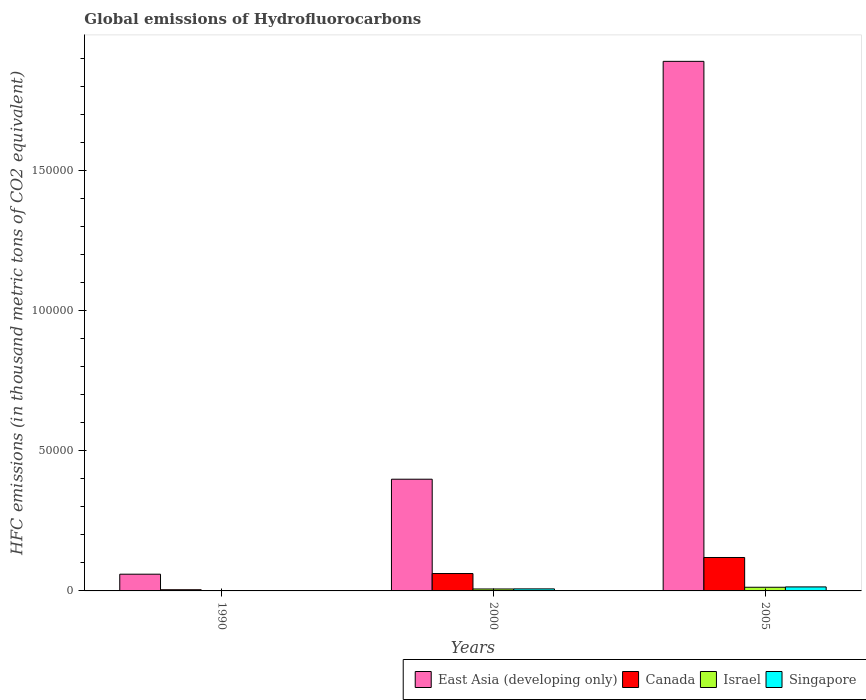How many different coloured bars are there?
Keep it short and to the point. 4. How many groups of bars are there?
Provide a succinct answer. 3. Are the number of bars per tick equal to the number of legend labels?
Make the answer very short. Yes. Are the number of bars on each tick of the X-axis equal?
Keep it short and to the point. Yes. How many bars are there on the 1st tick from the left?
Give a very brief answer. 4. How many bars are there on the 3rd tick from the right?
Your answer should be very brief. 4. What is the label of the 2nd group of bars from the left?
Your answer should be compact. 2000. In how many cases, is the number of bars for a given year not equal to the number of legend labels?
Ensure brevity in your answer.  0. What is the global emissions of Hydrofluorocarbons in Canada in 2000?
Make the answer very short. 6202.8. Across all years, what is the maximum global emissions of Hydrofluorocarbons in East Asia (developing only)?
Offer a terse response. 1.89e+05. In which year was the global emissions of Hydrofluorocarbons in Canada minimum?
Your answer should be compact. 1990. What is the total global emissions of Hydrofluorocarbons in Israel in the graph?
Make the answer very short. 2001.5. What is the difference between the global emissions of Hydrofluorocarbons in Canada in 1990 and that in 2005?
Keep it short and to the point. -1.15e+04. What is the difference between the global emissions of Hydrofluorocarbons in East Asia (developing only) in 2005 and the global emissions of Hydrofluorocarbons in Israel in 1990?
Offer a very short reply. 1.89e+05. What is the average global emissions of Hydrofluorocarbons in Israel per year?
Your response must be concise. 667.17. In the year 2005, what is the difference between the global emissions of Hydrofluorocarbons in Singapore and global emissions of Hydrofluorocarbons in East Asia (developing only)?
Your response must be concise. -1.88e+05. In how many years, is the global emissions of Hydrofluorocarbons in Canada greater than 180000 thousand metric tons?
Your answer should be compact. 0. What is the ratio of the global emissions of Hydrofluorocarbons in Canada in 2000 to that in 2005?
Provide a short and direct response. 0.52. Is the difference between the global emissions of Hydrofluorocarbons in Singapore in 1990 and 2005 greater than the difference between the global emissions of Hydrofluorocarbons in East Asia (developing only) in 1990 and 2005?
Give a very brief answer. Yes. What is the difference between the highest and the second highest global emissions of Hydrofluorocarbons in East Asia (developing only)?
Give a very brief answer. 1.49e+05. What is the difference between the highest and the lowest global emissions of Hydrofluorocarbons in Singapore?
Offer a very short reply. 1417.1. In how many years, is the global emissions of Hydrofluorocarbons in Singapore greater than the average global emissions of Hydrofluorocarbons in Singapore taken over all years?
Provide a short and direct response. 2. What does the 2nd bar from the right in 1990 represents?
Provide a succinct answer. Israel. How many years are there in the graph?
Ensure brevity in your answer.  3. Are the values on the major ticks of Y-axis written in scientific E-notation?
Your answer should be very brief. No. Does the graph contain any zero values?
Your answer should be compact. No. Where does the legend appear in the graph?
Your response must be concise. Bottom right. How are the legend labels stacked?
Your answer should be very brief. Horizontal. What is the title of the graph?
Keep it short and to the point. Global emissions of Hydrofluorocarbons. Does "Singapore" appear as one of the legend labels in the graph?
Provide a succinct answer. Yes. What is the label or title of the Y-axis?
Offer a terse response. HFC emissions (in thousand metric tons of CO2 equivalent). What is the HFC emissions (in thousand metric tons of CO2 equivalent) in East Asia (developing only) in 1990?
Ensure brevity in your answer.  5970.4. What is the HFC emissions (in thousand metric tons of CO2 equivalent) in Canada in 1990?
Offer a very short reply. 418.5. What is the HFC emissions (in thousand metric tons of CO2 equivalent) of Israel in 1990?
Your response must be concise. 4.6. What is the HFC emissions (in thousand metric tons of CO2 equivalent) in East Asia (developing only) in 2000?
Provide a succinct answer. 3.99e+04. What is the HFC emissions (in thousand metric tons of CO2 equivalent) in Canada in 2000?
Give a very brief answer. 6202.8. What is the HFC emissions (in thousand metric tons of CO2 equivalent) in Israel in 2000?
Your answer should be very brief. 691.9. What is the HFC emissions (in thousand metric tons of CO2 equivalent) of Singapore in 2000?
Offer a terse response. 728.9. What is the HFC emissions (in thousand metric tons of CO2 equivalent) in East Asia (developing only) in 2005?
Your answer should be compact. 1.89e+05. What is the HFC emissions (in thousand metric tons of CO2 equivalent) of Canada in 2005?
Ensure brevity in your answer.  1.19e+04. What is the HFC emissions (in thousand metric tons of CO2 equivalent) of Israel in 2005?
Provide a short and direct response. 1305. What is the HFC emissions (in thousand metric tons of CO2 equivalent) in Singapore in 2005?
Your response must be concise. 1429.7. Across all years, what is the maximum HFC emissions (in thousand metric tons of CO2 equivalent) in East Asia (developing only)?
Your response must be concise. 1.89e+05. Across all years, what is the maximum HFC emissions (in thousand metric tons of CO2 equivalent) in Canada?
Offer a terse response. 1.19e+04. Across all years, what is the maximum HFC emissions (in thousand metric tons of CO2 equivalent) in Israel?
Keep it short and to the point. 1305. Across all years, what is the maximum HFC emissions (in thousand metric tons of CO2 equivalent) of Singapore?
Offer a very short reply. 1429.7. Across all years, what is the minimum HFC emissions (in thousand metric tons of CO2 equivalent) in East Asia (developing only)?
Ensure brevity in your answer.  5970.4. Across all years, what is the minimum HFC emissions (in thousand metric tons of CO2 equivalent) in Canada?
Provide a succinct answer. 418.5. What is the total HFC emissions (in thousand metric tons of CO2 equivalent) in East Asia (developing only) in the graph?
Your answer should be very brief. 2.35e+05. What is the total HFC emissions (in thousand metric tons of CO2 equivalent) of Canada in the graph?
Make the answer very short. 1.85e+04. What is the total HFC emissions (in thousand metric tons of CO2 equivalent) in Israel in the graph?
Make the answer very short. 2001.5. What is the total HFC emissions (in thousand metric tons of CO2 equivalent) in Singapore in the graph?
Your response must be concise. 2171.2. What is the difference between the HFC emissions (in thousand metric tons of CO2 equivalent) of East Asia (developing only) in 1990 and that in 2000?
Offer a terse response. -3.39e+04. What is the difference between the HFC emissions (in thousand metric tons of CO2 equivalent) in Canada in 1990 and that in 2000?
Provide a short and direct response. -5784.3. What is the difference between the HFC emissions (in thousand metric tons of CO2 equivalent) of Israel in 1990 and that in 2000?
Give a very brief answer. -687.3. What is the difference between the HFC emissions (in thousand metric tons of CO2 equivalent) of Singapore in 1990 and that in 2000?
Keep it short and to the point. -716.3. What is the difference between the HFC emissions (in thousand metric tons of CO2 equivalent) of East Asia (developing only) in 1990 and that in 2005?
Your response must be concise. -1.83e+05. What is the difference between the HFC emissions (in thousand metric tons of CO2 equivalent) in Canada in 1990 and that in 2005?
Ensure brevity in your answer.  -1.15e+04. What is the difference between the HFC emissions (in thousand metric tons of CO2 equivalent) in Israel in 1990 and that in 2005?
Offer a terse response. -1300.4. What is the difference between the HFC emissions (in thousand metric tons of CO2 equivalent) of Singapore in 1990 and that in 2005?
Provide a short and direct response. -1417.1. What is the difference between the HFC emissions (in thousand metric tons of CO2 equivalent) in East Asia (developing only) in 2000 and that in 2005?
Make the answer very short. -1.49e+05. What is the difference between the HFC emissions (in thousand metric tons of CO2 equivalent) of Canada in 2000 and that in 2005?
Offer a terse response. -5725.6. What is the difference between the HFC emissions (in thousand metric tons of CO2 equivalent) of Israel in 2000 and that in 2005?
Offer a very short reply. -613.1. What is the difference between the HFC emissions (in thousand metric tons of CO2 equivalent) in Singapore in 2000 and that in 2005?
Your answer should be very brief. -700.8. What is the difference between the HFC emissions (in thousand metric tons of CO2 equivalent) of East Asia (developing only) in 1990 and the HFC emissions (in thousand metric tons of CO2 equivalent) of Canada in 2000?
Your answer should be very brief. -232.4. What is the difference between the HFC emissions (in thousand metric tons of CO2 equivalent) of East Asia (developing only) in 1990 and the HFC emissions (in thousand metric tons of CO2 equivalent) of Israel in 2000?
Give a very brief answer. 5278.5. What is the difference between the HFC emissions (in thousand metric tons of CO2 equivalent) in East Asia (developing only) in 1990 and the HFC emissions (in thousand metric tons of CO2 equivalent) in Singapore in 2000?
Your answer should be compact. 5241.5. What is the difference between the HFC emissions (in thousand metric tons of CO2 equivalent) of Canada in 1990 and the HFC emissions (in thousand metric tons of CO2 equivalent) of Israel in 2000?
Ensure brevity in your answer.  -273.4. What is the difference between the HFC emissions (in thousand metric tons of CO2 equivalent) in Canada in 1990 and the HFC emissions (in thousand metric tons of CO2 equivalent) in Singapore in 2000?
Make the answer very short. -310.4. What is the difference between the HFC emissions (in thousand metric tons of CO2 equivalent) in Israel in 1990 and the HFC emissions (in thousand metric tons of CO2 equivalent) in Singapore in 2000?
Provide a short and direct response. -724.3. What is the difference between the HFC emissions (in thousand metric tons of CO2 equivalent) in East Asia (developing only) in 1990 and the HFC emissions (in thousand metric tons of CO2 equivalent) in Canada in 2005?
Give a very brief answer. -5958. What is the difference between the HFC emissions (in thousand metric tons of CO2 equivalent) in East Asia (developing only) in 1990 and the HFC emissions (in thousand metric tons of CO2 equivalent) in Israel in 2005?
Your answer should be compact. 4665.4. What is the difference between the HFC emissions (in thousand metric tons of CO2 equivalent) of East Asia (developing only) in 1990 and the HFC emissions (in thousand metric tons of CO2 equivalent) of Singapore in 2005?
Provide a short and direct response. 4540.7. What is the difference between the HFC emissions (in thousand metric tons of CO2 equivalent) in Canada in 1990 and the HFC emissions (in thousand metric tons of CO2 equivalent) in Israel in 2005?
Your answer should be very brief. -886.5. What is the difference between the HFC emissions (in thousand metric tons of CO2 equivalent) in Canada in 1990 and the HFC emissions (in thousand metric tons of CO2 equivalent) in Singapore in 2005?
Provide a short and direct response. -1011.2. What is the difference between the HFC emissions (in thousand metric tons of CO2 equivalent) of Israel in 1990 and the HFC emissions (in thousand metric tons of CO2 equivalent) of Singapore in 2005?
Provide a succinct answer. -1425.1. What is the difference between the HFC emissions (in thousand metric tons of CO2 equivalent) in East Asia (developing only) in 2000 and the HFC emissions (in thousand metric tons of CO2 equivalent) in Canada in 2005?
Give a very brief answer. 2.79e+04. What is the difference between the HFC emissions (in thousand metric tons of CO2 equivalent) in East Asia (developing only) in 2000 and the HFC emissions (in thousand metric tons of CO2 equivalent) in Israel in 2005?
Your response must be concise. 3.86e+04. What is the difference between the HFC emissions (in thousand metric tons of CO2 equivalent) of East Asia (developing only) in 2000 and the HFC emissions (in thousand metric tons of CO2 equivalent) of Singapore in 2005?
Your answer should be compact. 3.84e+04. What is the difference between the HFC emissions (in thousand metric tons of CO2 equivalent) of Canada in 2000 and the HFC emissions (in thousand metric tons of CO2 equivalent) of Israel in 2005?
Provide a short and direct response. 4897.8. What is the difference between the HFC emissions (in thousand metric tons of CO2 equivalent) in Canada in 2000 and the HFC emissions (in thousand metric tons of CO2 equivalent) in Singapore in 2005?
Offer a very short reply. 4773.1. What is the difference between the HFC emissions (in thousand metric tons of CO2 equivalent) of Israel in 2000 and the HFC emissions (in thousand metric tons of CO2 equivalent) of Singapore in 2005?
Offer a terse response. -737.8. What is the average HFC emissions (in thousand metric tons of CO2 equivalent) in East Asia (developing only) per year?
Give a very brief answer. 7.83e+04. What is the average HFC emissions (in thousand metric tons of CO2 equivalent) of Canada per year?
Your answer should be very brief. 6183.23. What is the average HFC emissions (in thousand metric tons of CO2 equivalent) in Israel per year?
Offer a terse response. 667.17. What is the average HFC emissions (in thousand metric tons of CO2 equivalent) in Singapore per year?
Offer a very short reply. 723.73. In the year 1990, what is the difference between the HFC emissions (in thousand metric tons of CO2 equivalent) of East Asia (developing only) and HFC emissions (in thousand metric tons of CO2 equivalent) of Canada?
Provide a succinct answer. 5551.9. In the year 1990, what is the difference between the HFC emissions (in thousand metric tons of CO2 equivalent) of East Asia (developing only) and HFC emissions (in thousand metric tons of CO2 equivalent) of Israel?
Provide a succinct answer. 5965.8. In the year 1990, what is the difference between the HFC emissions (in thousand metric tons of CO2 equivalent) of East Asia (developing only) and HFC emissions (in thousand metric tons of CO2 equivalent) of Singapore?
Your answer should be compact. 5957.8. In the year 1990, what is the difference between the HFC emissions (in thousand metric tons of CO2 equivalent) in Canada and HFC emissions (in thousand metric tons of CO2 equivalent) in Israel?
Give a very brief answer. 413.9. In the year 1990, what is the difference between the HFC emissions (in thousand metric tons of CO2 equivalent) in Canada and HFC emissions (in thousand metric tons of CO2 equivalent) in Singapore?
Keep it short and to the point. 405.9. In the year 1990, what is the difference between the HFC emissions (in thousand metric tons of CO2 equivalent) in Israel and HFC emissions (in thousand metric tons of CO2 equivalent) in Singapore?
Your answer should be compact. -8. In the year 2000, what is the difference between the HFC emissions (in thousand metric tons of CO2 equivalent) in East Asia (developing only) and HFC emissions (in thousand metric tons of CO2 equivalent) in Canada?
Your answer should be very brief. 3.37e+04. In the year 2000, what is the difference between the HFC emissions (in thousand metric tons of CO2 equivalent) in East Asia (developing only) and HFC emissions (in thousand metric tons of CO2 equivalent) in Israel?
Provide a short and direct response. 3.92e+04. In the year 2000, what is the difference between the HFC emissions (in thousand metric tons of CO2 equivalent) of East Asia (developing only) and HFC emissions (in thousand metric tons of CO2 equivalent) of Singapore?
Your response must be concise. 3.91e+04. In the year 2000, what is the difference between the HFC emissions (in thousand metric tons of CO2 equivalent) in Canada and HFC emissions (in thousand metric tons of CO2 equivalent) in Israel?
Your answer should be very brief. 5510.9. In the year 2000, what is the difference between the HFC emissions (in thousand metric tons of CO2 equivalent) in Canada and HFC emissions (in thousand metric tons of CO2 equivalent) in Singapore?
Your response must be concise. 5473.9. In the year 2000, what is the difference between the HFC emissions (in thousand metric tons of CO2 equivalent) in Israel and HFC emissions (in thousand metric tons of CO2 equivalent) in Singapore?
Offer a terse response. -37. In the year 2005, what is the difference between the HFC emissions (in thousand metric tons of CO2 equivalent) of East Asia (developing only) and HFC emissions (in thousand metric tons of CO2 equivalent) of Canada?
Ensure brevity in your answer.  1.77e+05. In the year 2005, what is the difference between the HFC emissions (in thousand metric tons of CO2 equivalent) of East Asia (developing only) and HFC emissions (in thousand metric tons of CO2 equivalent) of Israel?
Your answer should be very brief. 1.88e+05. In the year 2005, what is the difference between the HFC emissions (in thousand metric tons of CO2 equivalent) of East Asia (developing only) and HFC emissions (in thousand metric tons of CO2 equivalent) of Singapore?
Give a very brief answer. 1.88e+05. In the year 2005, what is the difference between the HFC emissions (in thousand metric tons of CO2 equivalent) of Canada and HFC emissions (in thousand metric tons of CO2 equivalent) of Israel?
Give a very brief answer. 1.06e+04. In the year 2005, what is the difference between the HFC emissions (in thousand metric tons of CO2 equivalent) of Canada and HFC emissions (in thousand metric tons of CO2 equivalent) of Singapore?
Offer a terse response. 1.05e+04. In the year 2005, what is the difference between the HFC emissions (in thousand metric tons of CO2 equivalent) of Israel and HFC emissions (in thousand metric tons of CO2 equivalent) of Singapore?
Ensure brevity in your answer.  -124.7. What is the ratio of the HFC emissions (in thousand metric tons of CO2 equivalent) in East Asia (developing only) in 1990 to that in 2000?
Offer a terse response. 0.15. What is the ratio of the HFC emissions (in thousand metric tons of CO2 equivalent) in Canada in 1990 to that in 2000?
Offer a terse response. 0.07. What is the ratio of the HFC emissions (in thousand metric tons of CO2 equivalent) of Israel in 1990 to that in 2000?
Make the answer very short. 0.01. What is the ratio of the HFC emissions (in thousand metric tons of CO2 equivalent) in Singapore in 1990 to that in 2000?
Provide a short and direct response. 0.02. What is the ratio of the HFC emissions (in thousand metric tons of CO2 equivalent) in East Asia (developing only) in 1990 to that in 2005?
Make the answer very short. 0.03. What is the ratio of the HFC emissions (in thousand metric tons of CO2 equivalent) of Canada in 1990 to that in 2005?
Your answer should be compact. 0.04. What is the ratio of the HFC emissions (in thousand metric tons of CO2 equivalent) in Israel in 1990 to that in 2005?
Ensure brevity in your answer.  0. What is the ratio of the HFC emissions (in thousand metric tons of CO2 equivalent) of Singapore in 1990 to that in 2005?
Keep it short and to the point. 0.01. What is the ratio of the HFC emissions (in thousand metric tons of CO2 equivalent) in East Asia (developing only) in 2000 to that in 2005?
Give a very brief answer. 0.21. What is the ratio of the HFC emissions (in thousand metric tons of CO2 equivalent) of Canada in 2000 to that in 2005?
Your answer should be very brief. 0.52. What is the ratio of the HFC emissions (in thousand metric tons of CO2 equivalent) of Israel in 2000 to that in 2005?
Provide a short and direct response. 0.53. What is the ratio of the HFC emissions (in thousand metric tons of CO2 equivalent) in Singapore in 2000 to that in 2005?
Provide a short and direct response. 0.51. What is the difference between the highest and the second highest HFC emissions (in thousand metric tons of CO2 equivalent) in East Asia (developing only)?
Offer a terse response. 1.49e+05. What is the difference between the highest and the second highest HFC emissions (in thousand metric tons of CO2 equivalent) in Canada?
Ensure brevity in your answer.  5725.6. What is the difference between the highest and the second highest HFC emissions (in thousand metric tons of CO2 equivalent) in Israel?
Make the answer very short. 613.1. What is the difference between the highest and the second highest HFC emissions (in thousand metric tons of CO2 equivalent) of Singapore?
Your answer should be compact. 700.8. What is the difference between the highest and the lowest HFC emissions (in thousand metric tons of CO2 equivalent) of East Asia (developing only)?
Provide a short and direct response. 1.83e+05. What is the difference between the highest and the lowest HFC emissions (in thousand metric tons of CO2 equivalent) in Canada?
Give a very brief answer. 1.15e+04. What is the difference between the highest and the lowest HFC emissions (in thousand metric tons of CO2 equivalent) in Israel?
Provide a succinct answer. 1300.4. What is the difference between the highest and the lowest HFC emissions (in thousand metric tons of CO2 equivalent) of Singapore?
Your answer should be very brief. 1417.1. 